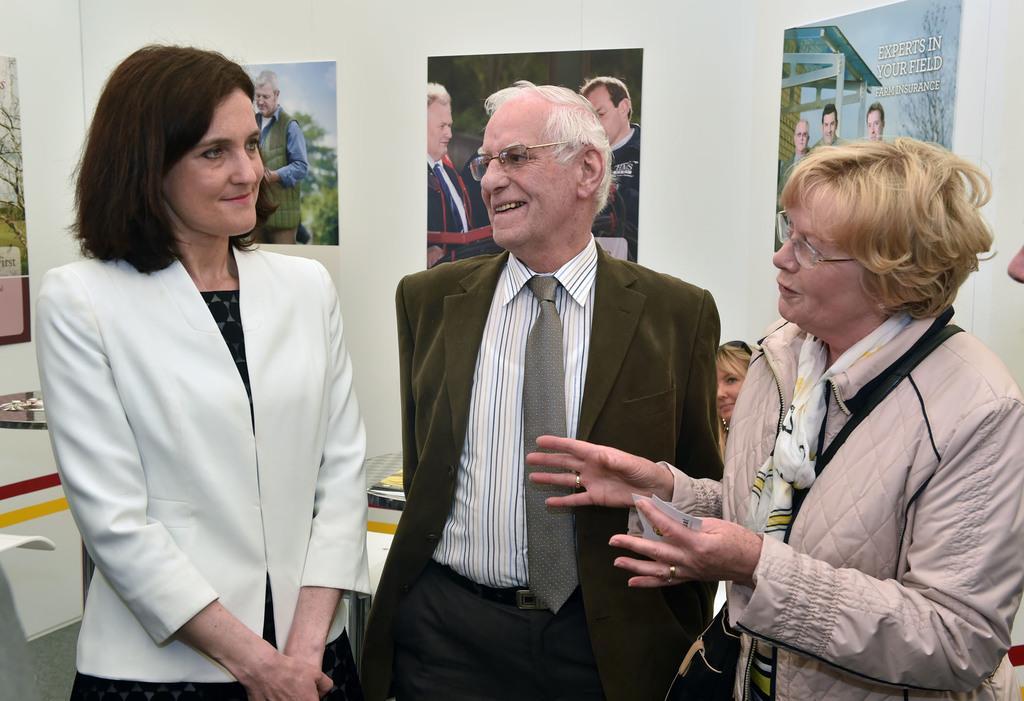In one or two sentences, can you explain what this image depicts? In this image there are two women standing, there is a man standing, there is a woman sitting, there is a woman talking, she is holding an object, there are tables, there are objects on the tables, there is a wall, there are photo frames on the wall, there is text on the photo frame, there are persons in the photo frame. 